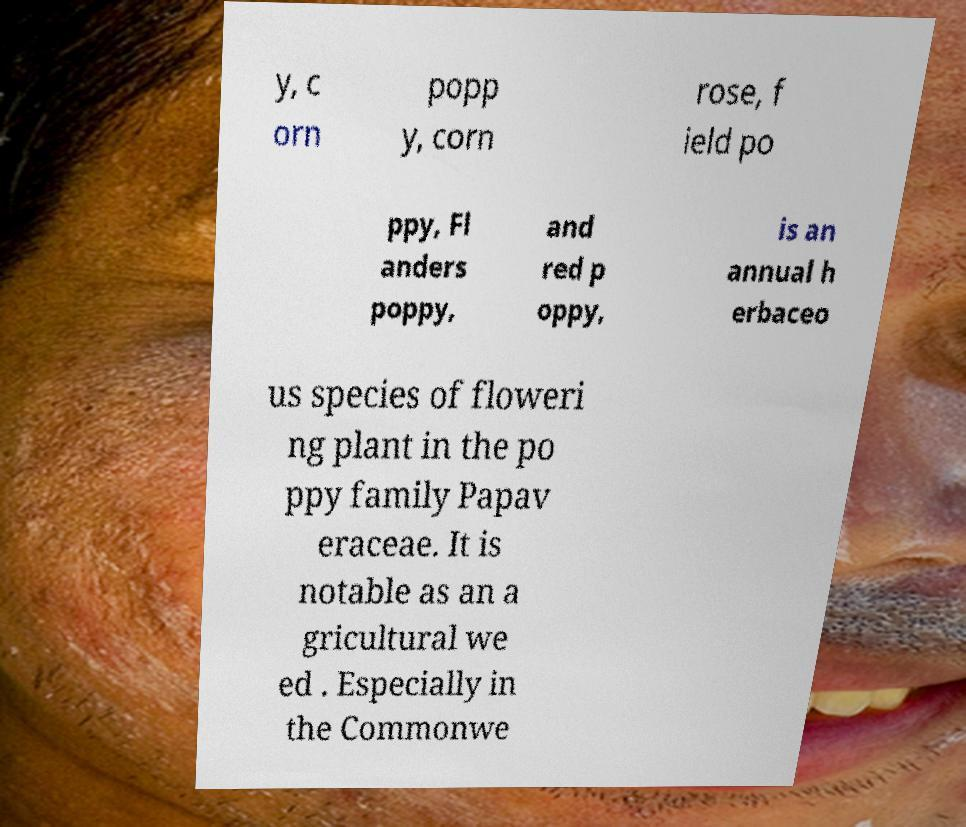There's text embedded in this image that I need extracted. Can you transcribe it verbatim? y, c orn popp y, corn rose, f ield po ppy, Fl anders poppy, and red p oppy, is an annual h erbaceo us species of floweri ng plant in the po ppy family Papav eraceae. It is notable as an a gricultural we ed . Especially in the Commonwe 